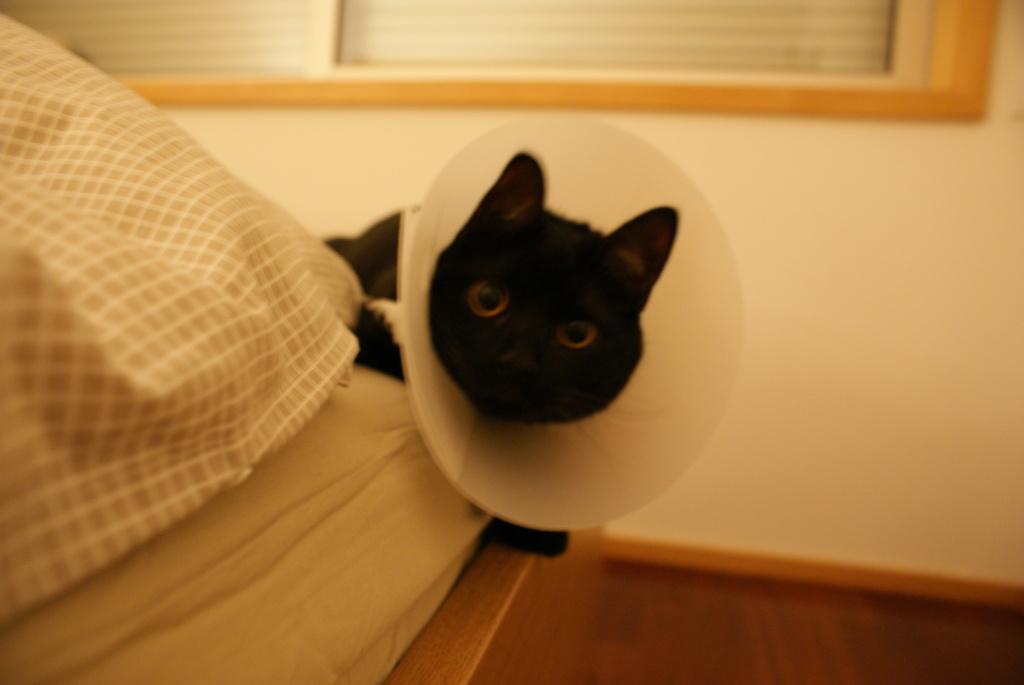Describe this image in one or two sentences. In the middle of the image there is a there is a cat, Behind the cat there is a wall. Bottom left side of the image there is a bed. 